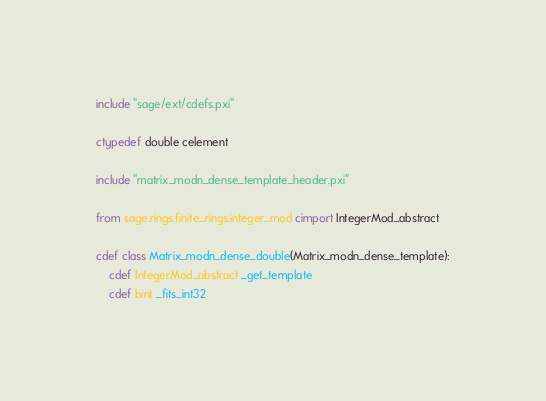<code> <loc_0><loc_0><loc_500><loc_500><_Cython_>include "sage/ext/cdefs.pxi"

ctypedef double celement

include "matrix_modn_dense_template_header.pxi"

from sage.rings.finite_rings.integer_mod cimport IntegerMod_abstract

cdef class Matrix_modn_dense_double(Matrix_modn_dense_template):
    cdef IntegerMod_abstract _get_template
    cdef bint _fits_int32
</code> 